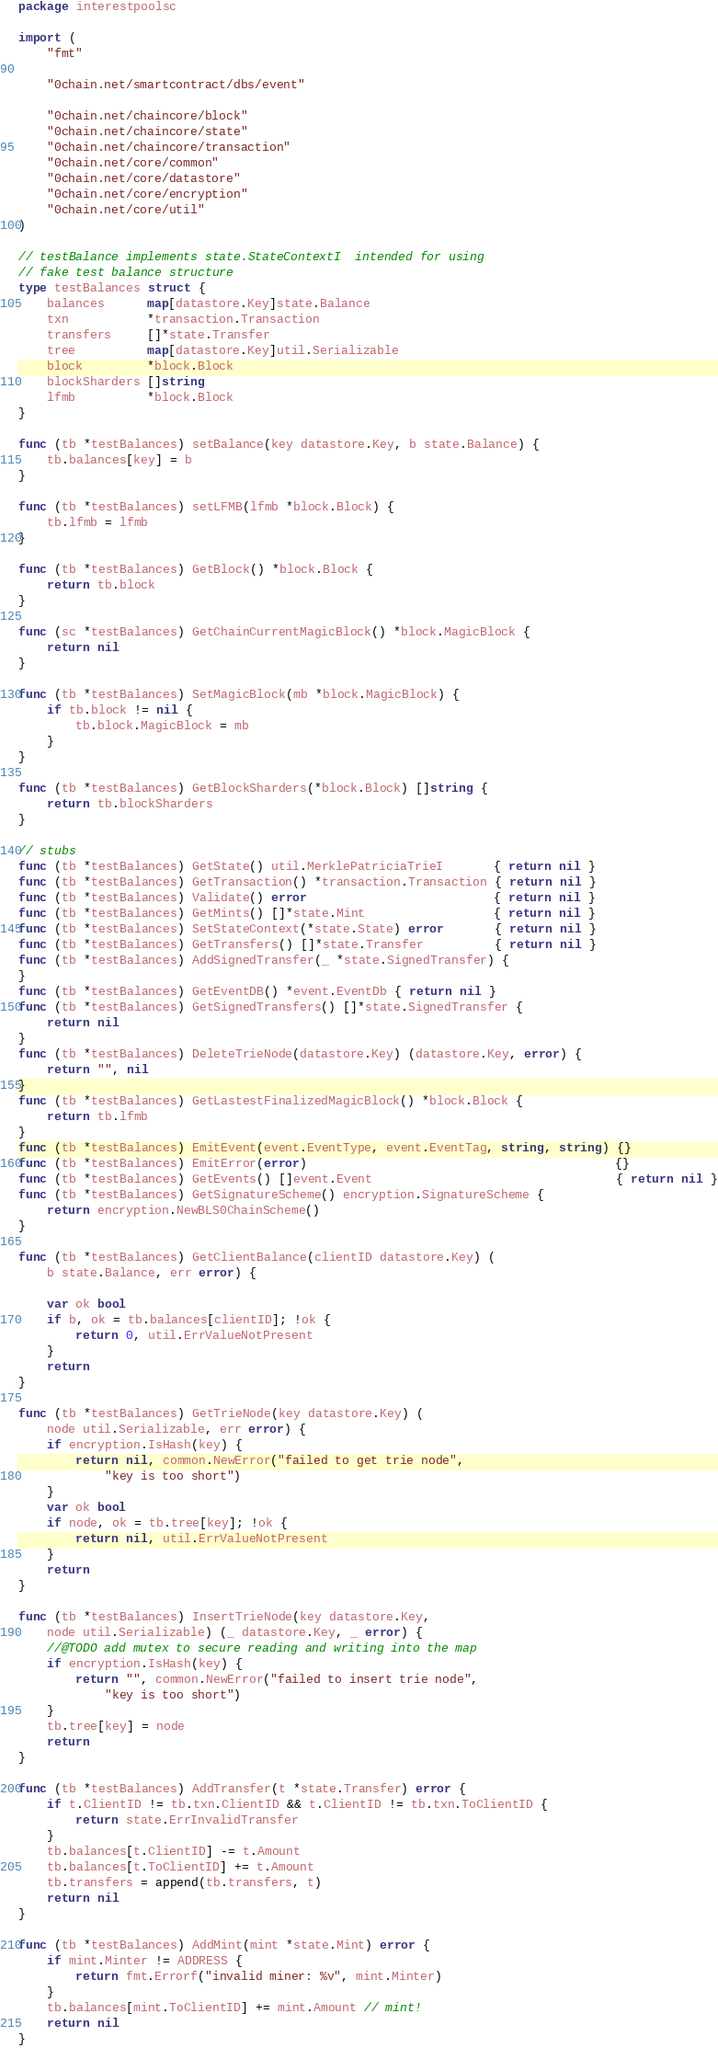Convert code to text. <code><loc_0><loc_0><loc_500><loc_500><_Go_>package interestpoolsc

import (
	"fmt"

	"0chain.net/smartcontract/dbs/event"

	"0chain.net/chaincore/block"
	"0chain.net/chaincore/state"
	"0chain.net/chaincore/transaction"
	"0chain.net/core/common"
	"0chain.net/core/datastore"
	"0chain.net/core/encryption"
	"0chain.net/core/util"
)

// testBalance implements state.StateContextI  intended for using
// fake test balance structure
type testBalances struct {
	balances      map[datastore.Key]state.Balance
	txn           *transaction.Transaction
	transfers     []*state.Transfer
	tree          map[datastore.Key]util.Serializable
	block         *block.Block
	blockSharders []string
	lfmb          *block.Block
}

func (tb *testBalances) setBalance(key datastore.Key, b state.Balance) {
	tb.balances[key] = b
}

func (tb *testBalances) setLFMB(lfmb *block.Block) {
	tb.lfmb = lfmb
}

func (tb *testBalances) GetBlock() *block.Block {
	return tb.block
}

func (sc *testBalances) GetChainCurrentMagicBlock() *block.MagicBlock {
	return nil
}

func (tb *testBalances) SetMagicBlock(mb *block.MagicBlock) {
	if tb.block != nil {
		tb.block.MagicBlock = mb
	}
}

func (tb *testBalances) GetBlockSharders(*block.Block) []string {
	return tb.blockSharders
}

// stubs
func (tb *testBalances) GetState() util.MerklePatriciaTrieI       { return nil }
func (tb *testBalances) GetTransaction() *transaction.Transaction { return nil }
func (tb *testBalances) Validate() error                          { return nil }
func (tb *testBalances) GetMints() []*state.Mint                  { return nil }
func (tb *testBalances) SetStateContext(*state.State) error       { return nil }
func (tb *testBalances) GetTransfers() []*state.Transfer          { return nil }
func (tb *testBalances) AddSignedTransfer(_ *state.SignedTransfer) {
}
func (tb *testBalances) GetEventDB() *event.EventDb { return nil }
func (tb *testBalances) GetSignedTransfers() []*state.SignedTransfer {
	return nil
}
func (tb *testBalances) DeleteTrieNode(datastore.Key) (datastore.Key, error) {
	return "", nil
}
func (tb *testBalances) GetLastestFinalizedMagicBlock() *block.Block {
	return tb.lfmb
}
func (tb *testBalances) EmitEvent(event.EventType, event.EventTag, string, string) {}
func (tb *testBalances) EmitError(error)                                           {}
func (tb *testBalances) GetEvents() []event.Event                                  { return nil }
func (tb *testBalances) GetSignatureScheme() encryption.SignatureScheme {
	return encryption.NewBLS0ChainScheme()
}

func (tb *testBalances) GetClientBalance(clientID datastore.Key) (
	b state.Balance, err error) {

	var ok bool
	if b, ok = tb.balances[clientID]; !ok {
		return 0, util.ErrValueNotPresent
	}
	return
}

func (tb *testBalances) GetTrieNode(key datastore.Key) (
	node util.Serializable, err error) {
	if encryption.IsHash(key) {
		return nil, common.NewError("failed to get trie node",
			"key is too short")
	}
	var ok bool
	if node, ok = tb.tree[key]; !ok {
		return nil, util.ErrValueNotPresent
	}
	return
}

func (tb *testBalances) InsertTrieNode(key datastore.Key,
	node util.Serializable) (_ datastore.Key, _ error) {
	//@TODO add mutex to secure reading and writing into the map
	if encryption.IsHash(key) {
		return "", common.NewError("failed to insert trie node",
			"key is too short")
	}
	tb.tree[key] = node
	return
}

func (tb *testBalances) AddTransfer(t *state.Transfer) error {
	if t.ClientID != tb.txn.ClientID && t.ClientID != tb.txn.ToClientID {
		return state.ErrInvalidTransfer
	}
	tb.balances[t.ClientID] -= t.Amount
	tb.balances[t.ToClientID] += t.Amount
	tb.transfers = append(tb.transfers, t)
	return nil
}

func (tb *testBalances) AddMint(mint *state.Mint) error {
	if mint.Minter != ADDRESS {
		return fmt.Errorf("invalid miner: %v", mint.Minter)
	}
	tb.balances[mint.ToClientID] += mint.Amount // mint!
	return nil
}
</code> 